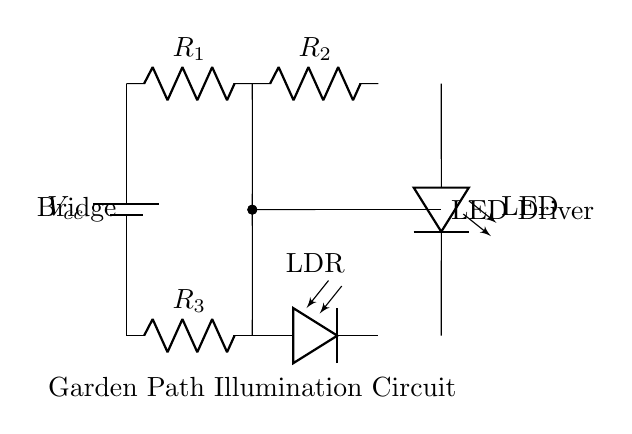What is the type of this circuit? The circuit is a bridge circuit, which is designed to compare the resistance of one path to another and adjust the output based on changes in light intensity captured by the LDR.
Answer: Bridge circuit What does LDR stand for? LDR stands for Light-Dependent Resistor, which changes its resistance based on the light intensity falling on it, helping to control the circuit's output in relation to ambient light.
Answer: Light-Dependent Resistor What component drives the LED? The PNP transistor acts as the LED driver by allowing current to flow through the LED when the circuit's conditions (such as light level) are met.
Answer: PNP transistor How many resistors are in the circuit? There are three resistors in the circuit: R1, R2, and R3, each serving different roles in establishing the bridge balance and controlling the current flow.
Answer: Three What is the role of the battery in this circuit? The battery provides the necessary voltage supply for the circuit to function, allowing current to flow and enabling the automatic illumination feature at dusk.
Answer: Voltage supply What happens to the LED when it gets dark? When it gets dark, the resistance of the LDR increases, causing the bridge circuit to activate the transistor, which in turn allows current to flow through the LED, illuminating the path.
Answer: Illuminates What is the output of the bridge circuit labeled as? The output of the bridge circuit is labeled as a connection point, which indicates where the illuminated signal is sent out, often to the LED driver component.
Answer: Connection point 